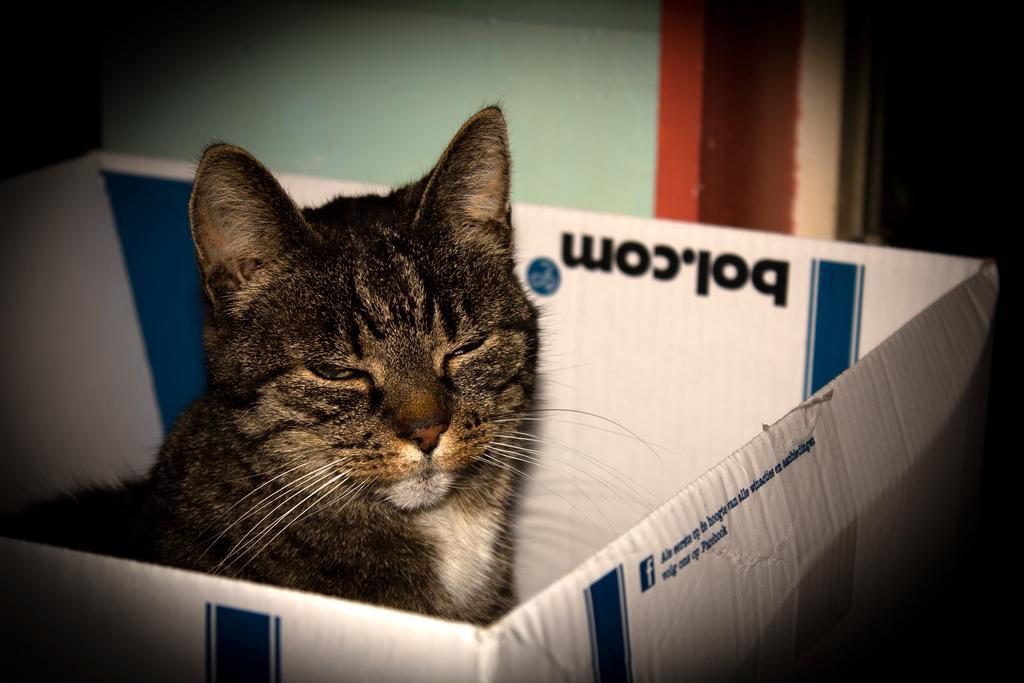Can you describe this image briefly? In this image we can see a cat sitting in a box. There is some text printed on the box. 